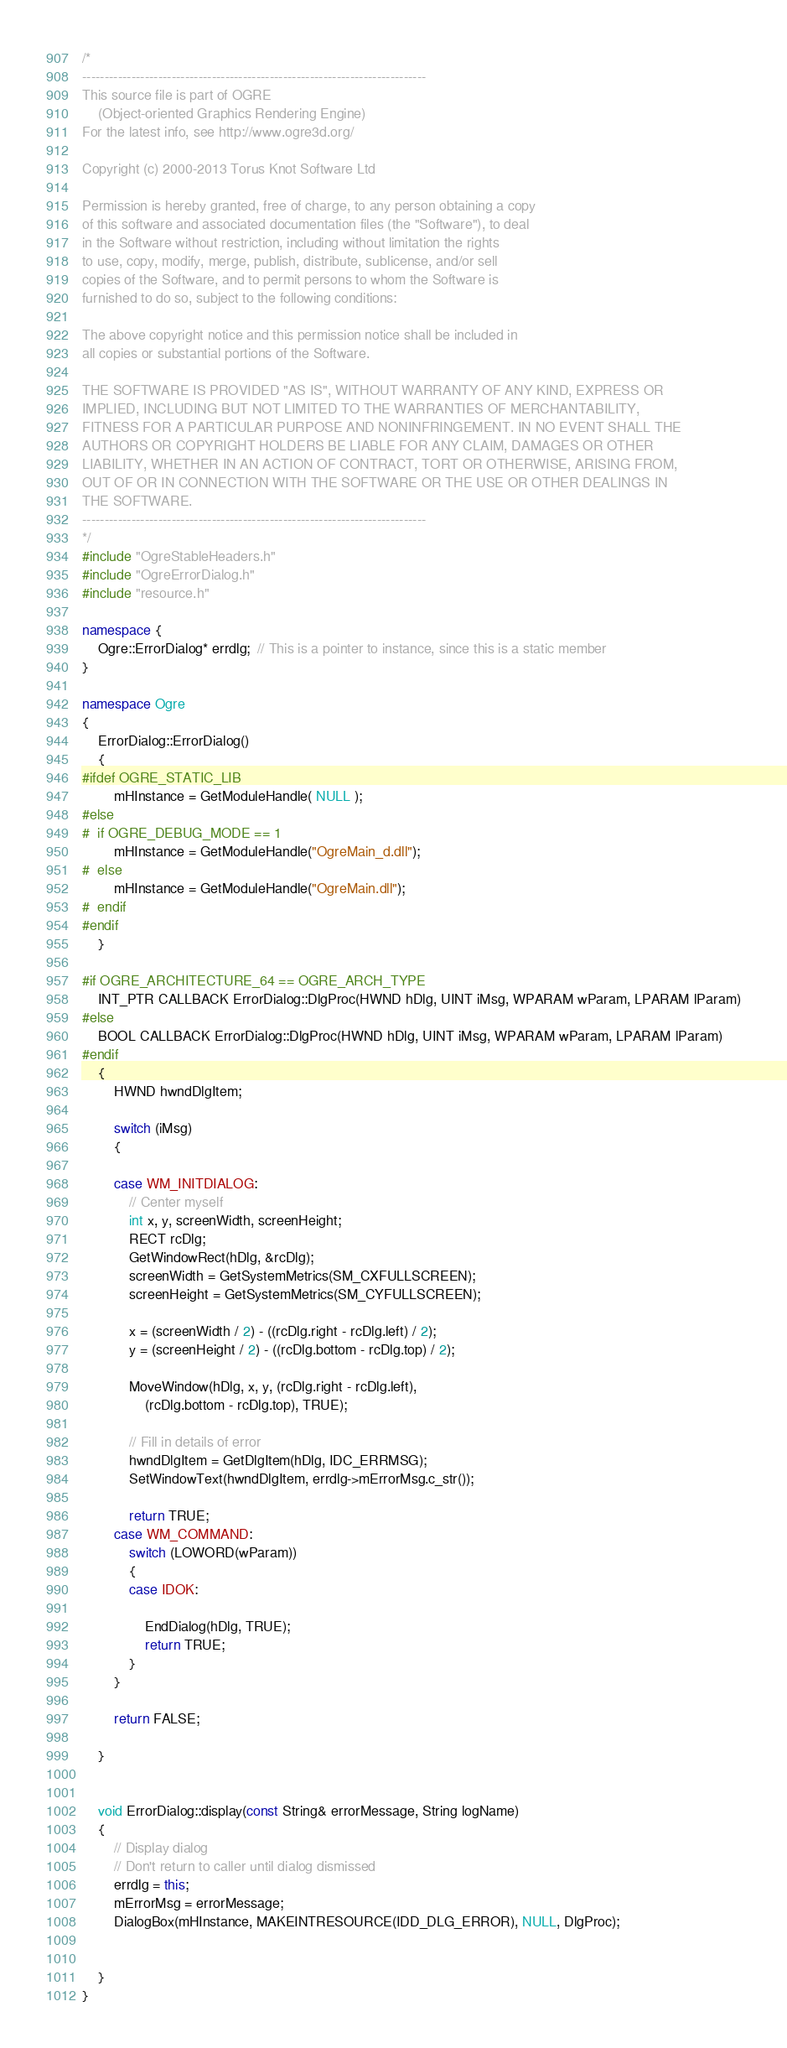<code> <loc_0><loc_0><loc_500><loc_500><_C++_>/*
-----------------------------------------------------------------------------
This source file is part of OGRE
    (Object-oriented Graphics Rendering Engine)
For the latest info, see http://www.ogre3d.org/

Copyright (c) 2000-2013 Torus Knot Software Ltd

Permission is hereby granted, free of charge, to any person obtaining a copy
of this software and associated documentation files (the "Software"), to deal
in the Software without restriction, including without limitation the rights
to use, copy, modify, merge, publish, distribute, sublicense, and/or sell
copies of the Software, and to permit persons to whom the Software is
furnished to do so, subject to the following conditions:

The above copyright notice and this permission notice shall be included in
all copies or substantial portions of the Software.

THE SOFTWARE IS PROVIDED "AS IS", WITHOUT WARRANTY OF ANY KIND, EXPRESS OR
IMPLIED, INCLUDING BUT NOT LIMITED TO THE WARRANTIES OF MERCHANTABILITY,
FITNESS FOR A PARTICULAR PURPOSE AND NONINFRINGEMENT. IN NO EVENT SHALL THE
AUTHORS OR COPYRIGHT HOLDERS BE LIABLE FOR ANY CLAIM, DAMAGES OR OTHER
LIABILITY, WHETHER IN AN ACTION OF CONTRACT, TORT OR OTHERWISE, ARISING FROM,
OUT OF OR IN CONNECTION WITH THE SOFTWARE OR THE USE OR OTHER DEALINGS IN
THE SOFTWARE.
-----------------------------------------------------------------------------
*/
#include "OgreStableHeaders.h"
#include "OgreErrorDialog.h"
#include "resource.h"

namespace {
    Ogre::ErrorDialog* errdlg;  // This is a pointer to instance, since this is a static member
}

namespace Ogre
{
    ErrorDialog::ErrorDialog()
    {
#ifdef OGRE_STATIC_LIB
		mHInstance = GetModuleHandle( NULL );
#else
#  if OGRE_DEBUG_MODE == 1
        mHInstance = GetModuleHandle("OgreMain_d.dll");
#  else
        mHInstance = GetModuleHandle("OgreMain.dll");
#  endif
#endif
    }

#if OGRE_ARCHITECTURE_64 == OGRE_ARCH_TYPE
    INT_PTR CALLBACK ErrorDialog::DlgProc(HWND hDlg, UINT iMsg, WPARAM wParam, LPARAM lParam)
#else
    BOOL CALLBACK ErrorDialog::DlgProc(HWND hDlg, UINT iMsg, WPARAM wParam, LPARAM lParam)
#endif
    {
        HWND hwndDlgItem;

        switch (iMsg)
        {

        case WM_INITDIALOG:
            // Center myself
            int x, y, screenWidth, screenHeight;
            RECT rcDlg;
            GetWindowRect(hDlg, &rcDlg);
            screenWidth = GetSystemMetrics(SM_CXFULLSCREEN);
            screenHeight = GetSystemMetrics(SM_CYFULLSCREEN);

            x = (screenWidth / 2) - ((rcDlg.right - rcDlg.left) / 2);
            y = (screenHeight / 2) - ((rcDlg.bottom - rcDlg.top) / 2);

            MoveWindow(hDlg, x, y, (rcDlg.right - rcDlg.left),
                (rcDlg.bottom - rcDlg.top), TRUE);

            // Fill in details of error
            hwndDlgItem = GetDlgItem(hDlg, IDC_ERRMSG);
            SetWindowText(hwndDlgItem, errdlg->mErrorMsg.c_str());

            return TRUE;
        case WM_COMMAND:
            switch (LOWORD(wParam))
            {
            case IDOK:

                EndDialog(hDlg, TRUE);
                return TRUE;
            }
        }

        return FALSE;

    }


    void ErrorDialog::display(const String& errorMessage, String logName)
    {
        // Display dialog
        // Don't return to caller until dialog dismissed
        errdlg = this;
        mErrorMsg = errorMessage;
        DialogBox(mHInstance, MAKEINTRESOURCE(IDD_DLG_ERROR), NULL, DlgProc);


    }
}
</code> 